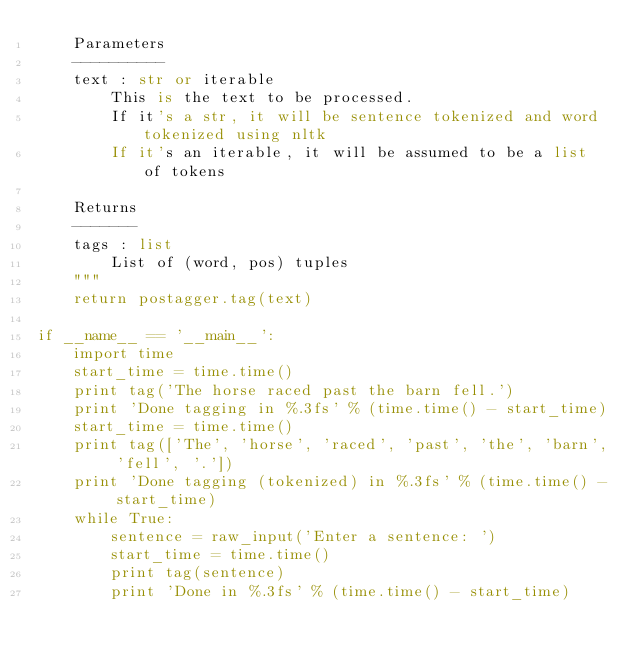<code> <loc_0><loc_0><loc_500><loc_500><_Python_>    Parameters
    ----------
    text : str or iterable
        This is the text to be processed.
        If it's a str, it will be sentence tokenized and word tokenized using nltk
        If it's an iterable, it will be assumed to be a list of tokens

    Returns
    -------
    tags : list
        List of (word, pos) tuples
    """
    return postagger.tag(text)

if __name__ == '__main__':
    import time
    start_time = time.time()
    print tag('The horse raced past the barn fell.')
    print 'Done tagging in %.3fs' % (time.time() - start_time)
    start_time = time.time()
    print tag(['The', 'horse', 'raced', 'past', 'the', 'barn', 'fell', '.'])
    print 'Done tagging (tokenized) in %.3fs' % (time.time() - start_time)
    while True:
        sentence = raw_input('Enter a sentence: ')
        start_time = time.time()
        print tag(sentence)
        print 'Done in %.3fs' % (time.time() - start_time)
</code> 